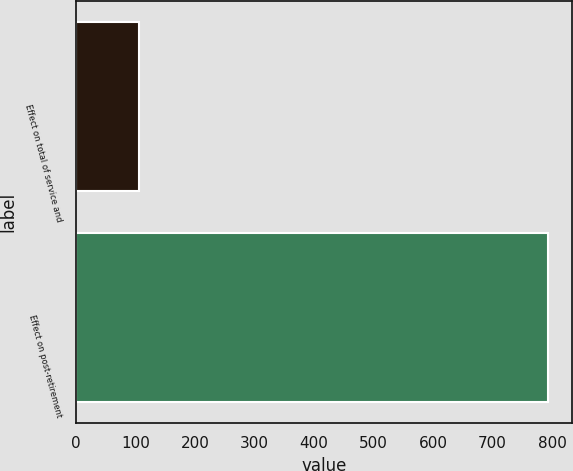Convert chart to OTSL. <chart><loc_0><loc_0><loc_500><loc_500><bar_chart><fcel>Effect on total of service and<fcel>Effect on post-retirement<nl><fcel>106<fcel>793<nl></chart> 